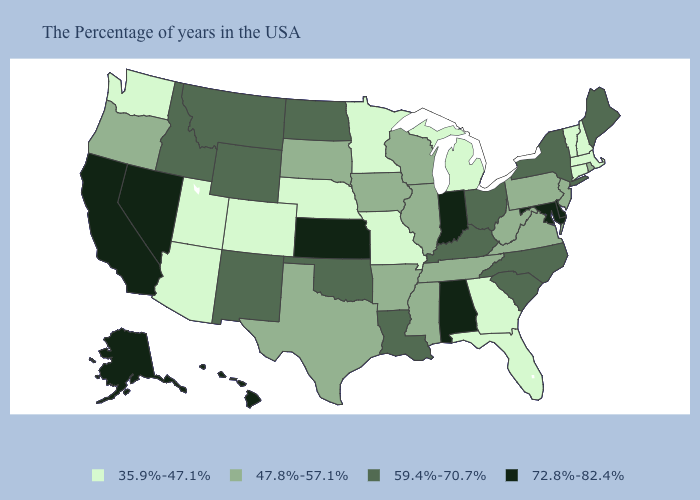How many symbols are there in the legend?
Answer briefly. 4. What is the highest value in states that border Nebraska?
Keep it brief. 72.8%-82.4%. What is the value of Mississippi?
Short answer required. 47.8%-57.1%. Does Nevada have the lowest value in the West?
Write a very short answer. No. What is the value of Wyoming?
Keep it brief. 59.4%-70.7%. Does South Dakota have the highest value in the MidWest?
Keep it brief. No. Does Iowa have a lower value than South Dakota?
Be succinct. No. Does Maine have the highest value in the Northeast?
Concise answer only. Yes. What is the value of Texas?
Give a very brief answer. 47.8%-57.1%. Does Hawaii have the highest value in the USA?
Quick response, please. Yes. What is the lowest value in states that border Arizona?
Quick response, please. 35.9%-47.1%. Which states hav the highest value in the Northeast?
Be succinct. Maine, New York. What is the value of Kentucky?
Write a very short answer. 59.4%-70.7%. What is the value of Idaho?
Short answer required. 59.4%-70.7%. What is the value of Mississippi?
Be succinct. 47.8%-57.1%. 